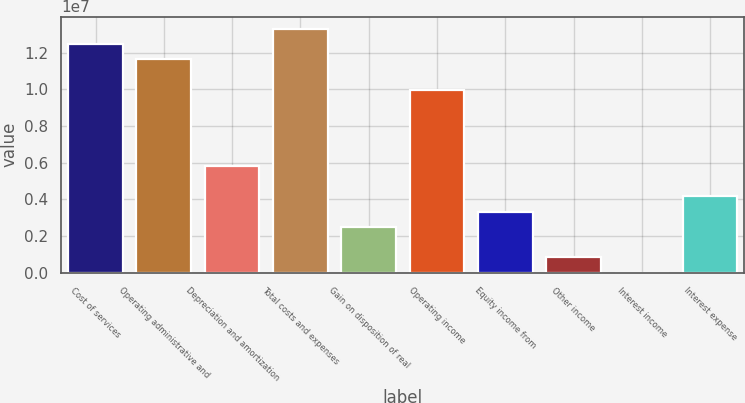Convert chart. <chart><loc_0><loc_0><loc_500><loc_500><bar_chart><fcel>Cost of services<fcel>Operating administrative and<fcel>Depreciation and amortization<fcel>Total costs and expenses<fcel>Gain on disposition of real<fcel>Operating income<fcel>Equity income from<fcel>Other income<fcel>Interest income<fcel>Interest expense<nl><fcel>1.24699e+07<fcel>1.1639e+07<fcel>5.8226e+06<fcel>1.33008e+07<fcel>2.49896e+06<fcel>9.97714e+06<fcel>3.32987e+06<fcel>837142<fcel>6233<fcel>4.16078e+06<nl></chart> 